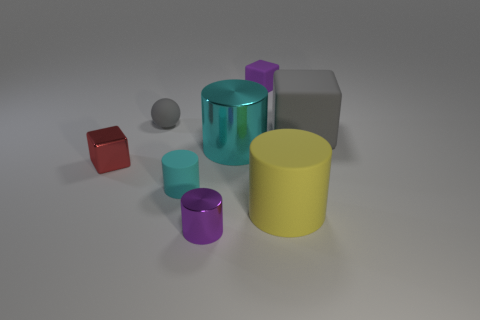What number of gray shiny objects have the same size as the cyan rubber object?
Give a very brief answer. 0. There is a tiny cylinder that is made of the same material as the small sphere; what is its color?
Ensure brevity in your answer.  Cyan. Are there fewer small metal blocks behind the tiny metallic block than big gray matte things?
Your response must be concise. Yes. What shape is the small gray object that is the same material as the small cyan cylinder?
Offer a terse response. Sphere. How many matte objects are large blocks or brown cubes?
Keep it short and to the point. 1. Are there the same number of shiny cubes that are to the left of the big yellow thing and small gray matte balls?
Your answer should be compact. Yes. Do the tiny matte object that is on the right side of the tiny matte cylinder and the small metallic cylinder have the same color?
Provide a short and direct response. Yes. The small object that is both right of the small rubber cylinder and behind the yellow matte thing is made of what material?
Your response must be concise. Rubber. There is a small purple object in front of the big cyan shiny thing; are there any cyan cylinders that are behind it?
Offer a very short reply. Yes. Does the large yellow cylinder have the same material as the purple cylinder?
Keep it short and to the point. No. 